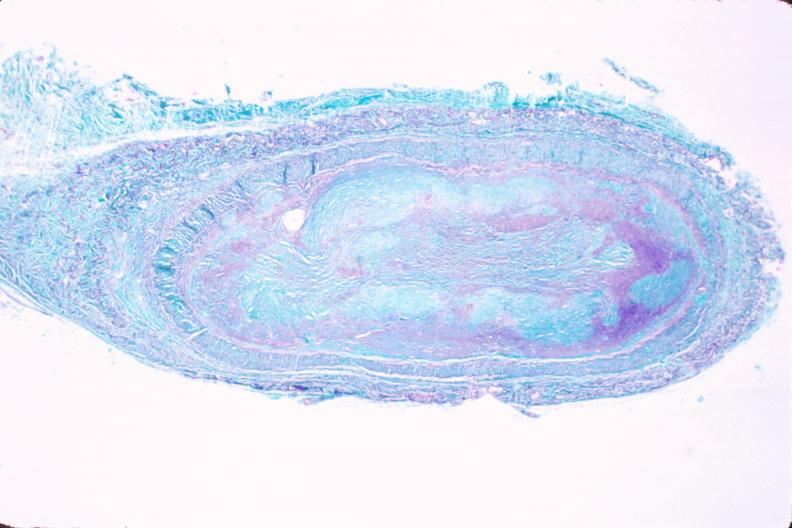where is this in?
Answer the question using a single word or phrase. In vasculature 